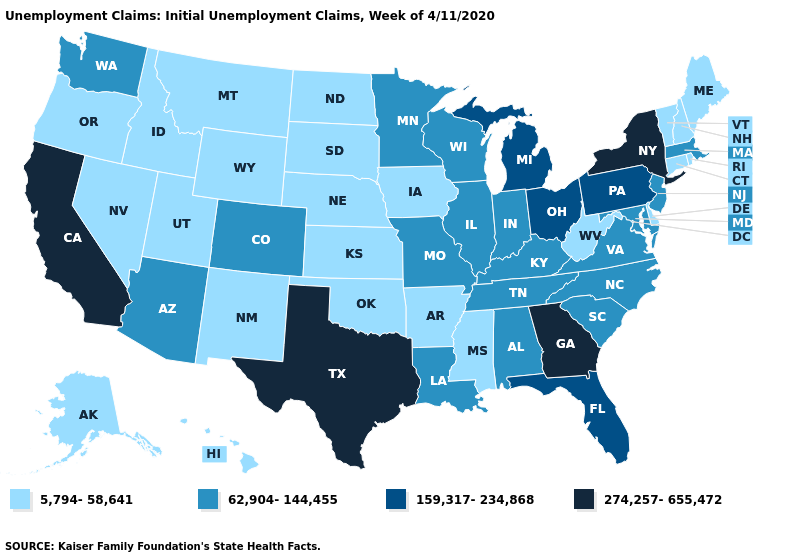What is the value of Kentucky?
Be succinct. 62,904-144,455. Does Delaware have a higher value than Kansas?
Answer briefly. No. What is the value of Oklahoma?
Answer briefly. 5,794-58,641. Name the states that have a value in the range 274,257-655,472?
Answer briefly. California, Georgia, New York, Texas. What is the value of Washington?
Concise answer only. 62,904-144,455. What is the highest value in states that border Ohio?
Short answer required. 159,317-234,868. Among the states that border Virginia , which have the highest value?
Write a very short answer. Kentucky, Maryland, North Carolina, Tennessee. Among the states that border Nebraska , does Colorado have the lowest value?
Write a very short answer. No. Name the states that have a value in the range 159,317-234,868?
Concise answer only. Florida, Michigan, Ohio, Pennsylvania. Does the first symbol in the legend represent the smallest category?
Write a very short answer. Yes. What is the value of Louisiana?
Concise answer only. 62,904-144,455. Name the states that have a value in the range 159,317-234,868?
Keep it brief. Florida, Michigan, Ohio, Pennsylvania. Among the states that border Wisconsin , which have the lowest value?
Answer briefly. Iowa. Does the map have missing data?
Give a very brief answer. No. Name the states that have a value in the range 274,257-655,472?
Be succinct. California, Georgia, New York, Texas. 